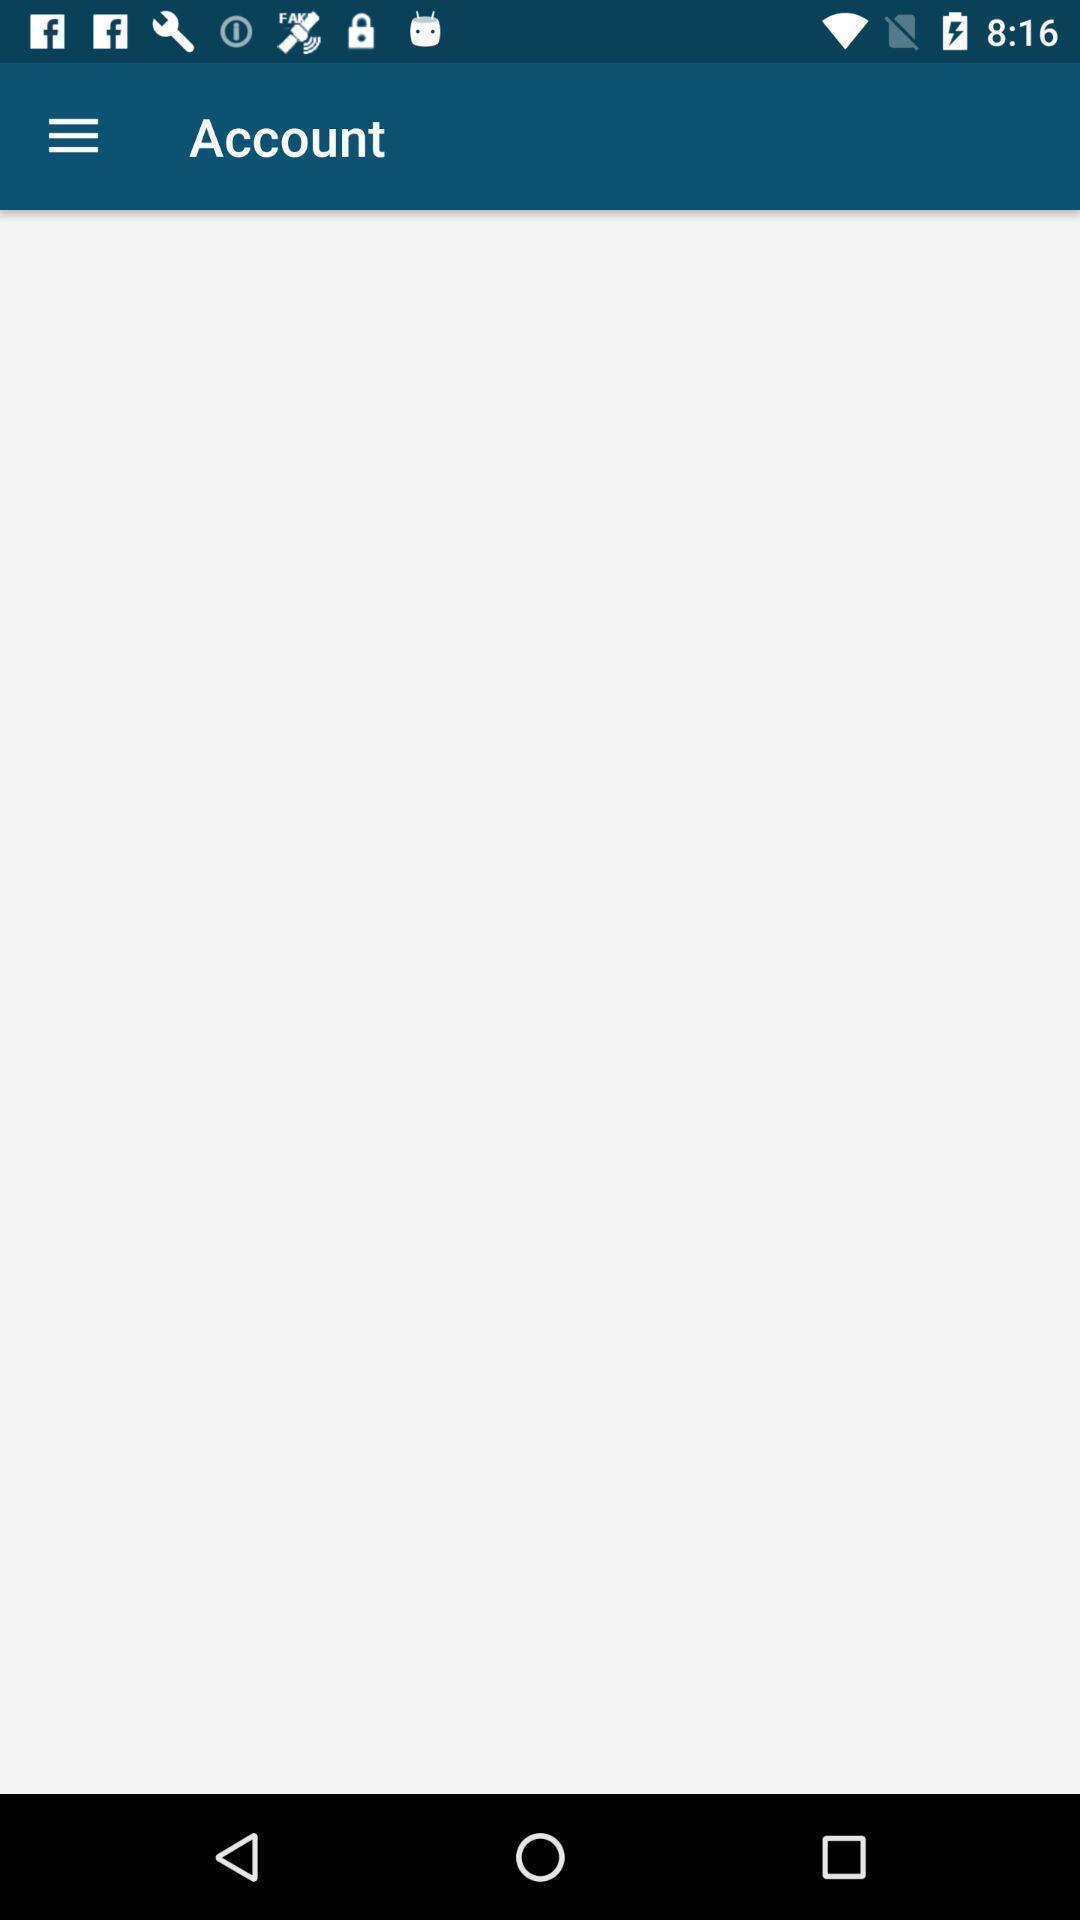Summarize the information in this screenshot. Screen page for the financial app. 